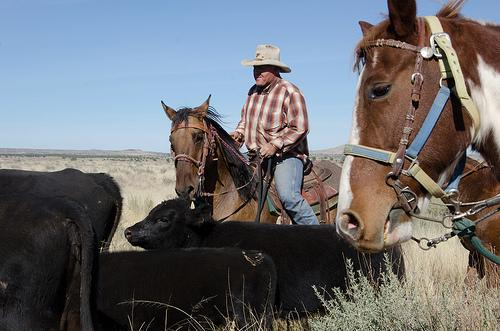Can you identify any distinctive feature on the calf in the image? The calf has missing fur on its hind quarters. Briefly describe the scene depicted in the image. A cowboy on horseback, wearing a plaid shirt and a hat, is herding black cattle with the help of three brown horses and using green ropes and harnesses. Count the total number of horses and cows in the image. There are 3 horses and 4 cows in the image. How many brown horses are assisting the man in the image, and what is their main purpose? There are three brown horses assisting the man, and their main purpose is to corral the cattle. What color and pattern is the man's shirt in the picture? The man's shirt is checkered with a plaid pattern. Describe an accessory worn by the horse in the image. The horse is wearing a silver buckle on its harness and yellow straps. What type of clothing is the man in the image wearing? The man is wearing a plaid button-down shirt, blue jeans, and a white cowboy hat. Using details from the image, describe the man's role and main activity. The man's role is to act as a cowboy, and his main activity involves herding cattle on horseback while holding the horse's reins with his left hand. What color are the cattle being herded in the image, and what is their current action? The cattle are black in color, and they are walking as they are being herded. What is the color and position of the weeds in the image? The weeds are tall, green, and located next to a brown horse. 